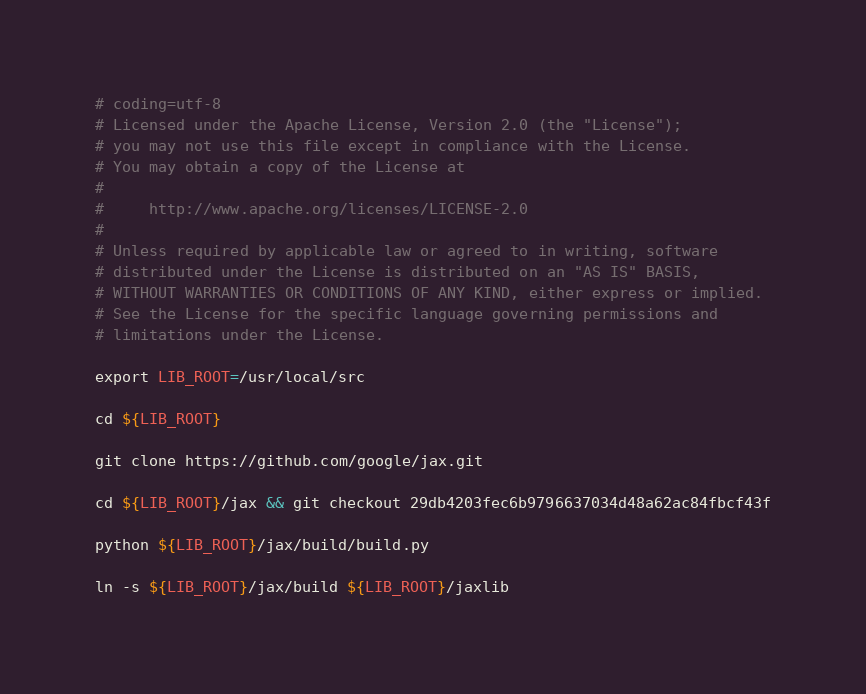Convert code to text. <code><loc_0><loc_0><loc_500><loc_500><_Bash_># coding=utf-8
# Licensed under the Apache License, Version 2.0 (the "License");
# you may not use this file except in compliance with the License.
# You may obtain a copy of the License at
#
#     http://www.apache.org/licenses/LICENSE-2.0
#
# Unless required by applicable law or agreed to in writing, software
# distributed under the License is distributed on an "AS IS" BASIS,
# WITHOUT WARRANTIES OR CONDITIONS OF ANY KIND, either express or implied.
# See the License for the specific language governing permissions and
# limitations under the License.

export LIB_ROOT=/usr/local/src

cd ${LIB_ROOT}

git clone https://github.com/google/jax.git

cd ${LIB_ROOT}/jax && git checkout 29db4203fec6b9796637034d48a62ac84fbcf43f

python ${LIB_ROOT}/jax/build/build.py

ln -s ${LIB_ROOT}/jax/build ${LIB_ROOT}/jaxlib
</code> 